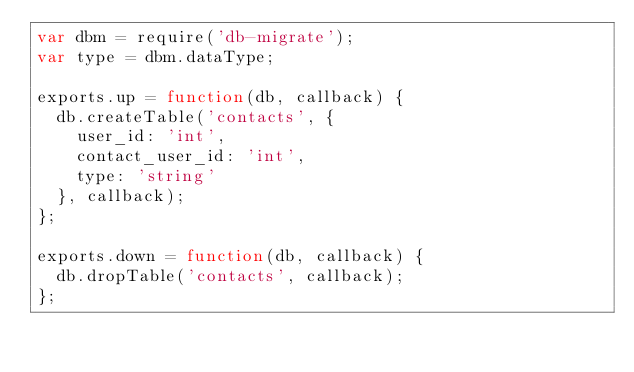<code> <loc_0><loc_0><loc_500><loc_500><_JavaScript_>var dbm = require('db-migrate');
var type = dbm.dataType;

exports.up = function(db, callback) {
  db.createTable('contacts', {
    user_id: 'int',
    contact_user_id: 'int',
    type: 'string'
  }, callback);
};

exports.down = function(db, callback) {
  db.dropTable('contacts', callback);
};
</code> 